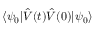Convert formula to latex. <formula><loc_0><loc_0><loc_500><loc_500>\langle \psi _ { 0 } | \hat { V } ( t ) \hat { V } ( 0 ) | \psi _ { 0 } \rangle</formula> 